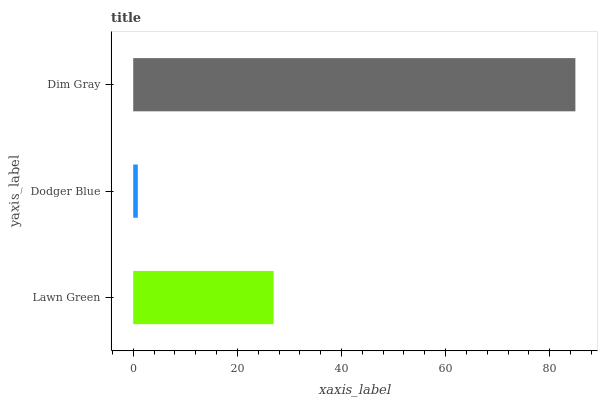Is Dodger Blue the minimum?
Answer yes or no. Yes. Is Dim Gray the maximum?
Answer yes or no. Yes. Is Dim Gray the minimum?
Answer yes or no. No. Is Dodger Blue the maximum?
Answer yes or no. No. Is Dim Gray greater than Dodger Blue?
Answer yes or no. Yes. Is Dodger Blue less than Dim Gray?
Answer yes or no. Yes. Is Dodger Blue greater than Dim Gray?
Answer yes or no. No. Is Dim Gray less than Dodger Blue?
Answer yes or no. No. Is Lawn Green the high median?
Answer yes or no. Yes. Is Lawn Green the low median?
Answer yes or no. Yes. Is Dim Gray the high median?
Answer yes or no. No. Is Dodger Blue the low median?
Answer yes or no. No. 